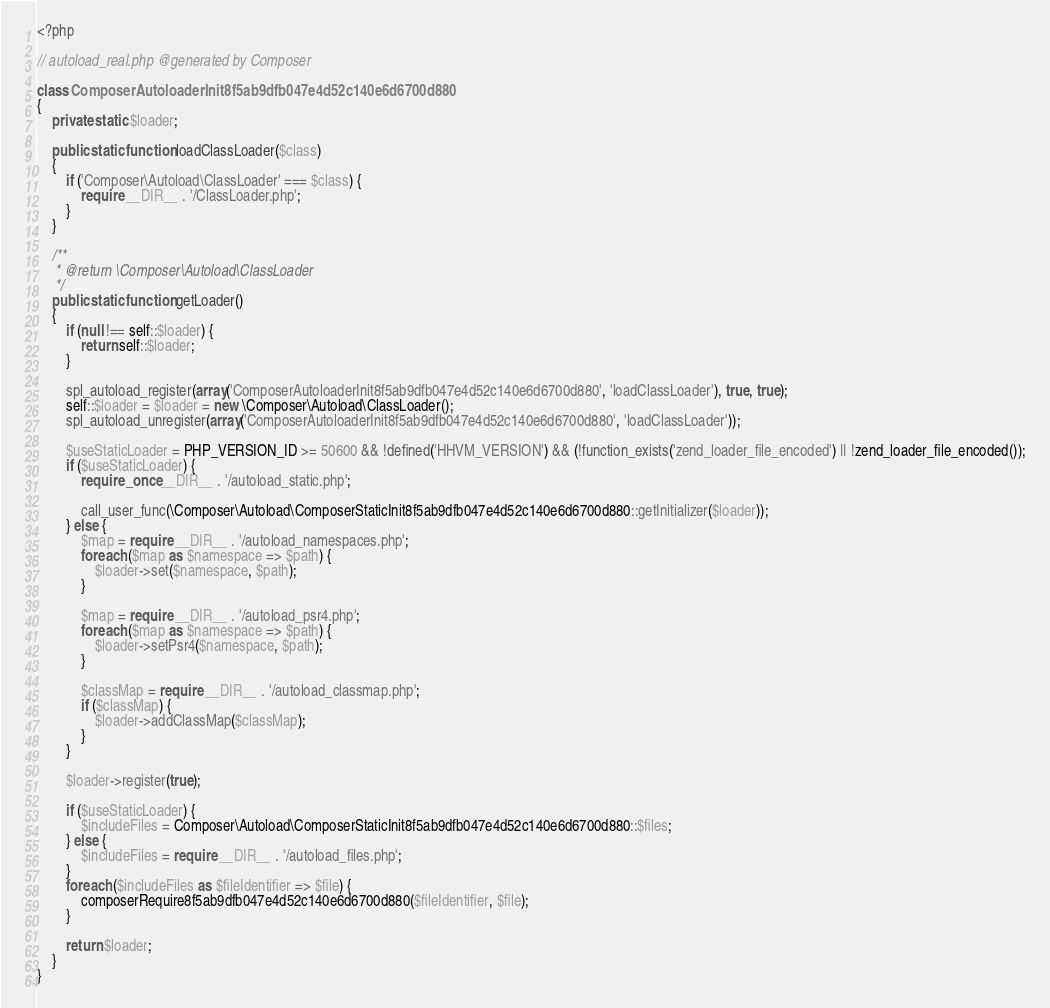Convert code to text. <code><loc_0><loc_0><loc_500><loc_500><_PHP_><?php

// autoload_real.php @generated by Composer

class ComposerAutoloaderInit8f5ab9dfb047e4d52c140e6d6700d880
{
    private static $loader;

    public static function loadClassLoader($class)
    {
        if ('Composer\Autoload\ClassLoader' === $class) {
            require __DIR__ . '/ClassLoader.php';
        }
    }

    /**
     * @return \Composer\Autoload\ClassLoader
     */
    public static function getLoader()
    {
        if (null !== self::$loader) {
            return self::$loader;
        }

        spl_autoload_register(array('ComposerAutoloaderInit8f5ab9dfb047e4d52c140e6d6700d880', 'loadClassLoader'), true, true);
        self::$loader = $loader = new \Composer\Autoload\ClassLoader();
        spl_autoload_unregister(array('ComposerAutoloaderInit8f5ab9dfb047e4d52c140e6d6700d880', 'loadClassLoader'));

        $useStaticLoader = PHP_VERSION_ID >= 50600 && !defined('HHVM_VERSION') && (!function_exists('zend_loader_file_encoded') || !zend_loader_file_encoded());
        if ($useStaticLoader) {
            require_once __DIR__ . '/autoload_static.php';

            call_user_func(\Composer\Autoload\ComposerStaticInit8f5ab9dfb047e4d52c140e6d6700d880::getInitializer($loader));
        } else {
            $map = require __DIR__ . '/autoload_namespaces.php';
            foreach ($map as $namespace => $path) {
                $loader->set($namespace, $path);
            }

            $map = require __DIR__ . '/autoload_psr4.php';
            foreach ($map as $namespace => $path) {
                $loader->setPsr4($namespace, $path);
            }

            $classMap = require __DIR__ . '/autoload_classmap.php';
            if ($classMap) {
                $loader->addClassMap($classMap);
            }
        }

        $loader->register(true);

        if ($useStaticLoader) {
            $includeFiles = Composer\Autoload\ComposerStaticInit8f5ab9dfb047e4d52c140e6d6700d880::$files;
        } else {
            $includeFiles = require __DIR__ . '/autoload_files.php';
        }
        foreach ($includeFiles as $fileIdentifier => $file) {
            composerRequire8f5ab9dfb047e4d52c140e6d6700d880($fileIdentifier, $file);
        }

        return $loader;
    }
}
</code> 